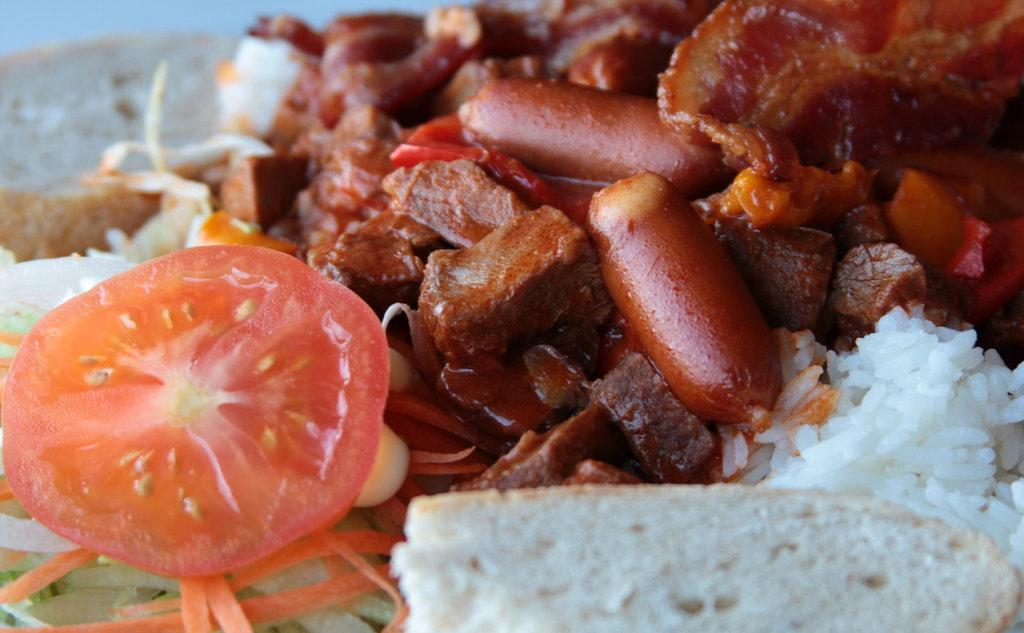What type of fruit or vegetable is present in the image? There is a tomato and a carrot in the image. What type of grain is present in the image? There is rice in the image. What type of food item is commonly used for making sandwiches? There is bread in the image. What other food items can be seen in the image besides the ones mentioned? There are other unspecified food items in the image. What type of animal is present in the image, and what is the color of its tail? There are no animals present in the image, so it is not possible to answer the question about the color of a tail. 